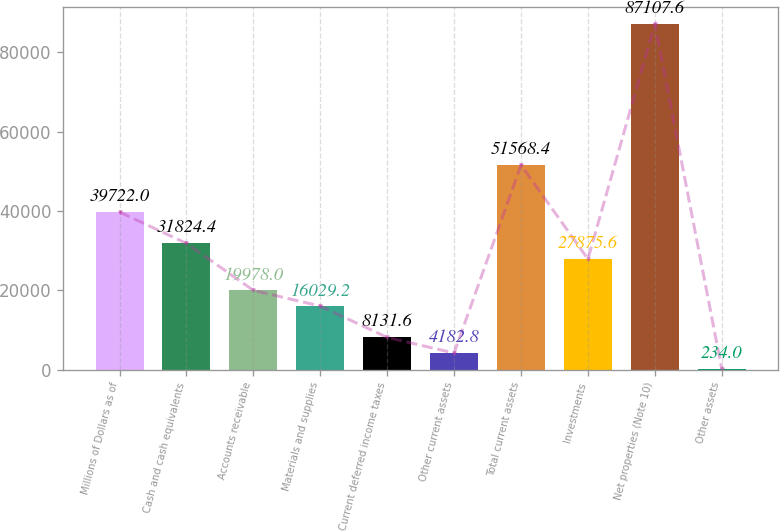<chart> <loc_0><loc_0><loc_500><loc_500><bar_chart><fcel>Millions of Dollars as of<fcel>Cash and cash equivalents<fcel>Accounts receivable<fcel>Materials and supplies<fcel>Current deferred income taxes<fcel>Other current assets<fcel>Total current assets<fcel>Investments<fcel>Net properties (Note 10)<fcel>Other assets<nl><fcel>39722<fcel>31824.4<fcel>19978<fcel>16029.2<fcel>8131.6<fcel>4182.8<fcel>51568.4<fcel>27875.6<fcel>87107.6<fcel>234<nl></chart> 